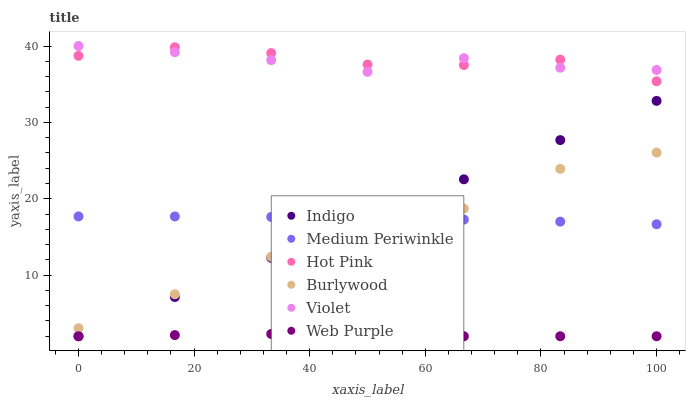Does Web Purple have the minimum area under the curve?
Answer yes or no. Yes. Does Hot Pink have the maximum area under the curve?
Answer yes or no. Yes. Does Burlywood have the minimum area under the curve?
Answer yes or no. No. Does Burlywood have the maximum area under the curve?
Answer yes or no. No. Is Indigo the smoothest?
Answer yes or no. Yes. Is Hot Pink the roughest?
Answer yes or no. Yes. Is Burlywood the smoothest?
Answer yes or no. No. Is Burlywood the roughest?
Answer yes or no. No. Does Indigo have the lowest value?
Answer yes or no. Yes. Does Burlywood have the lowest value?
Answer yes or no. No. Does Violet have the highest value?
Answer yes or no. Yes. Does Burlywood have the highest value?
Answer yes or no. No. Is Medium Periwinkle less than Hot Pink?
Answer yes or no. Yes. Is Medium Periwinkle greater than Web Purple?
Answer yes or no. Yes. Does Hot Pink intersect Violet?
Answer yes or no. Yes. Is Hot Pink less than Violet?
Answer yes or no. No. Is Hot Pink greater than Violet?
Answer yes or no. No. Does Medium Periwinkle intersect Hot Pink?
Answer yes or no. No. 